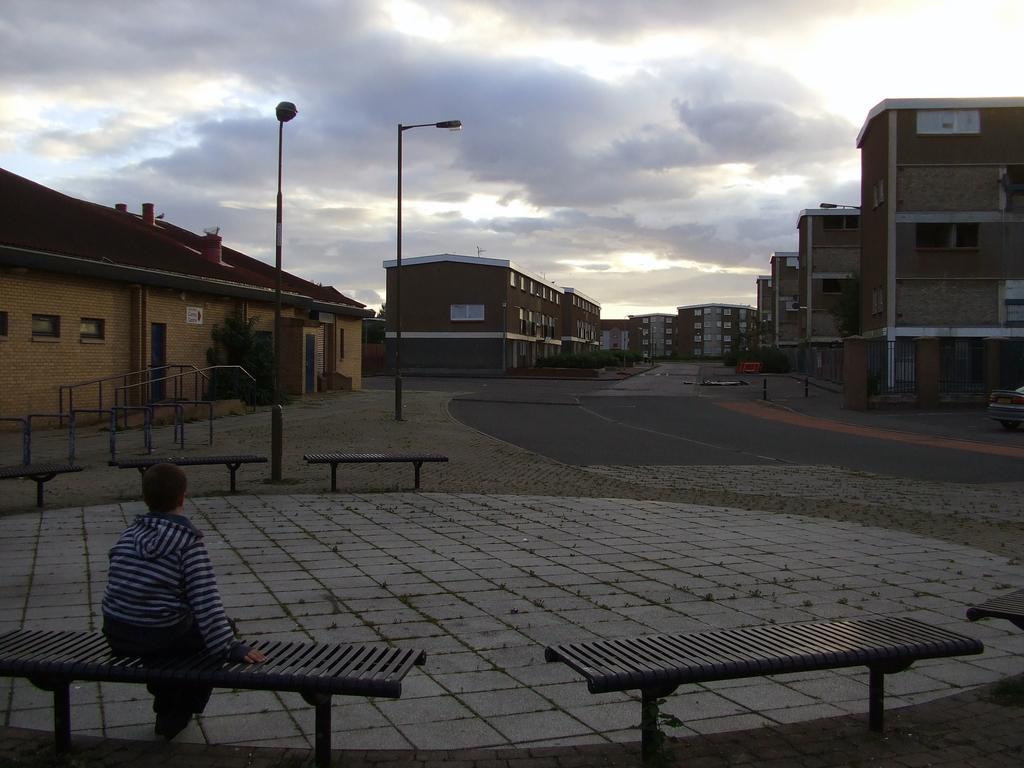How would you summarize this image in a sentence or two? In this image I see a few benches and I see this person is sitting over here, In the background I see road, buildings, 2 poles and the sky. 